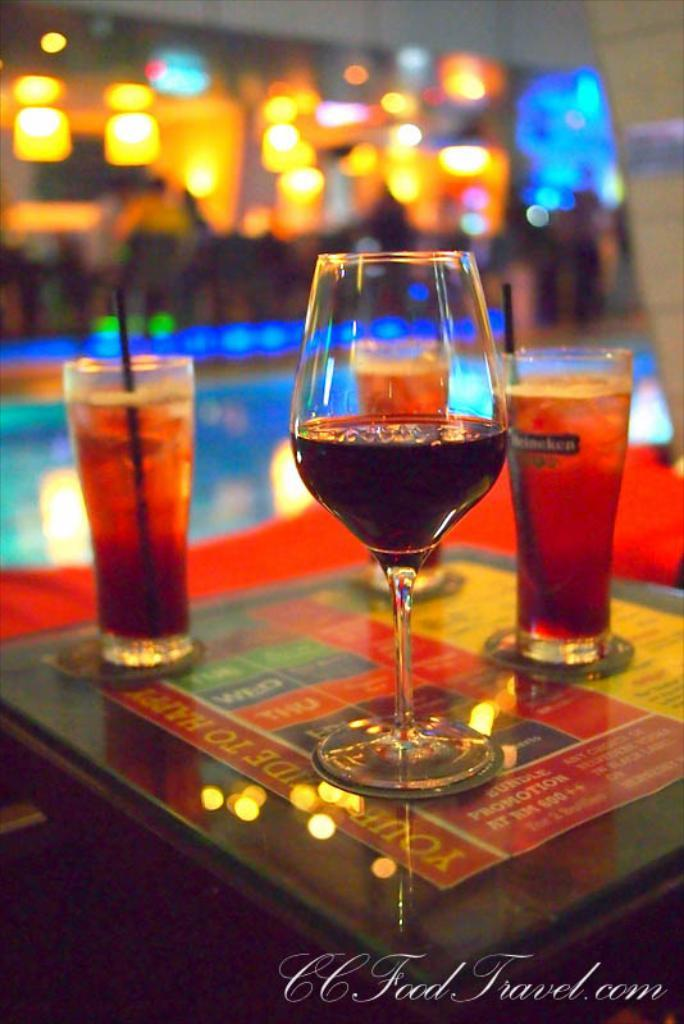What objects are in the image that people might use for drinking? There are glasses in the image. What is contained within the glasses? There is liquid in the glasses. What can be seen in the background of the image? There are lights visible in the background of the image. What type of anger can be seen on the faces of the people in the image? There are no people or faces present in the image, so it is not possible to determine if there is any anger visible. 